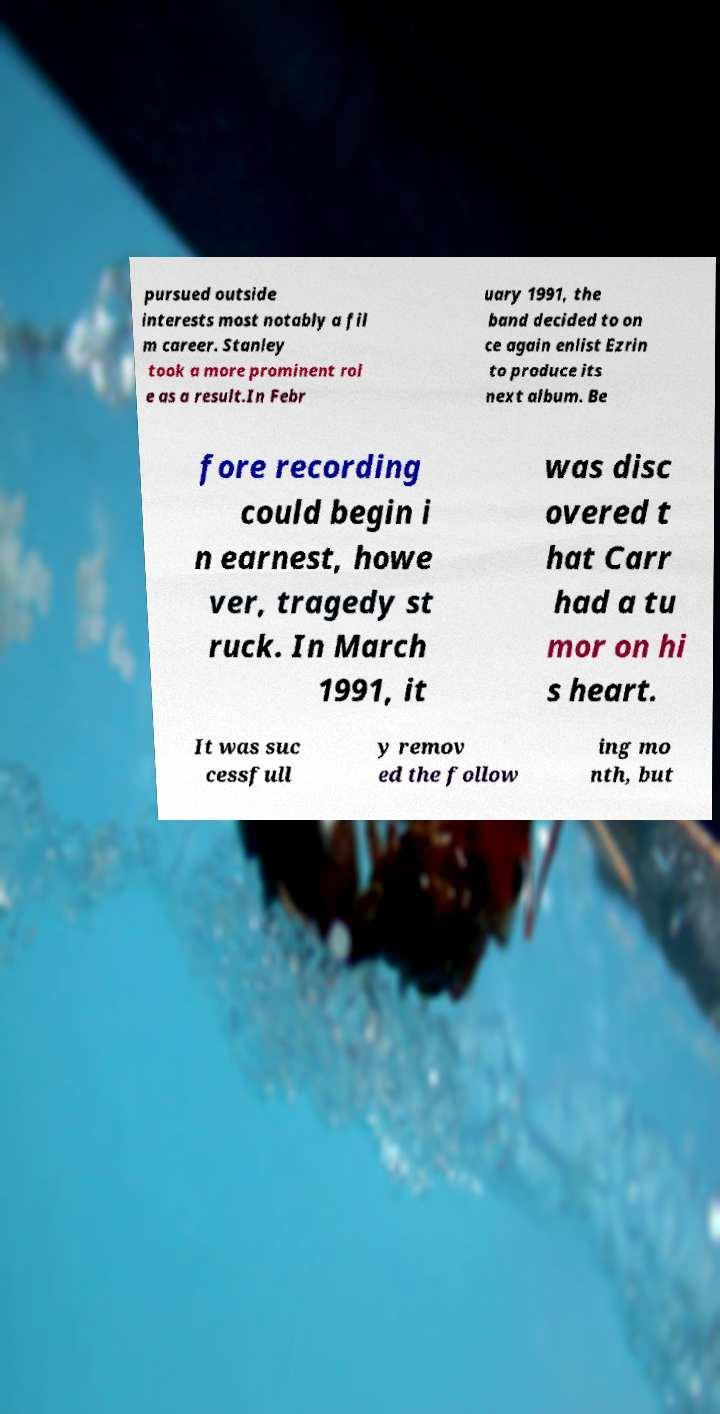Please read and relay the text visible in this image. What does it say? pursued outside interests most notably a fil m career. Stanley took a more prominent rol e as a result.In Febr uary 1991, the band decided to on ce again enlist Ezrin to produce its next album. Be fore recording could begin i n earnest, howe ver, tragedy st ruck. In March 1991, it was disc overed t hat Carr had a tu mor on hi s heart. It was suc cessfull y remov ed the follow ing mo nth, but 